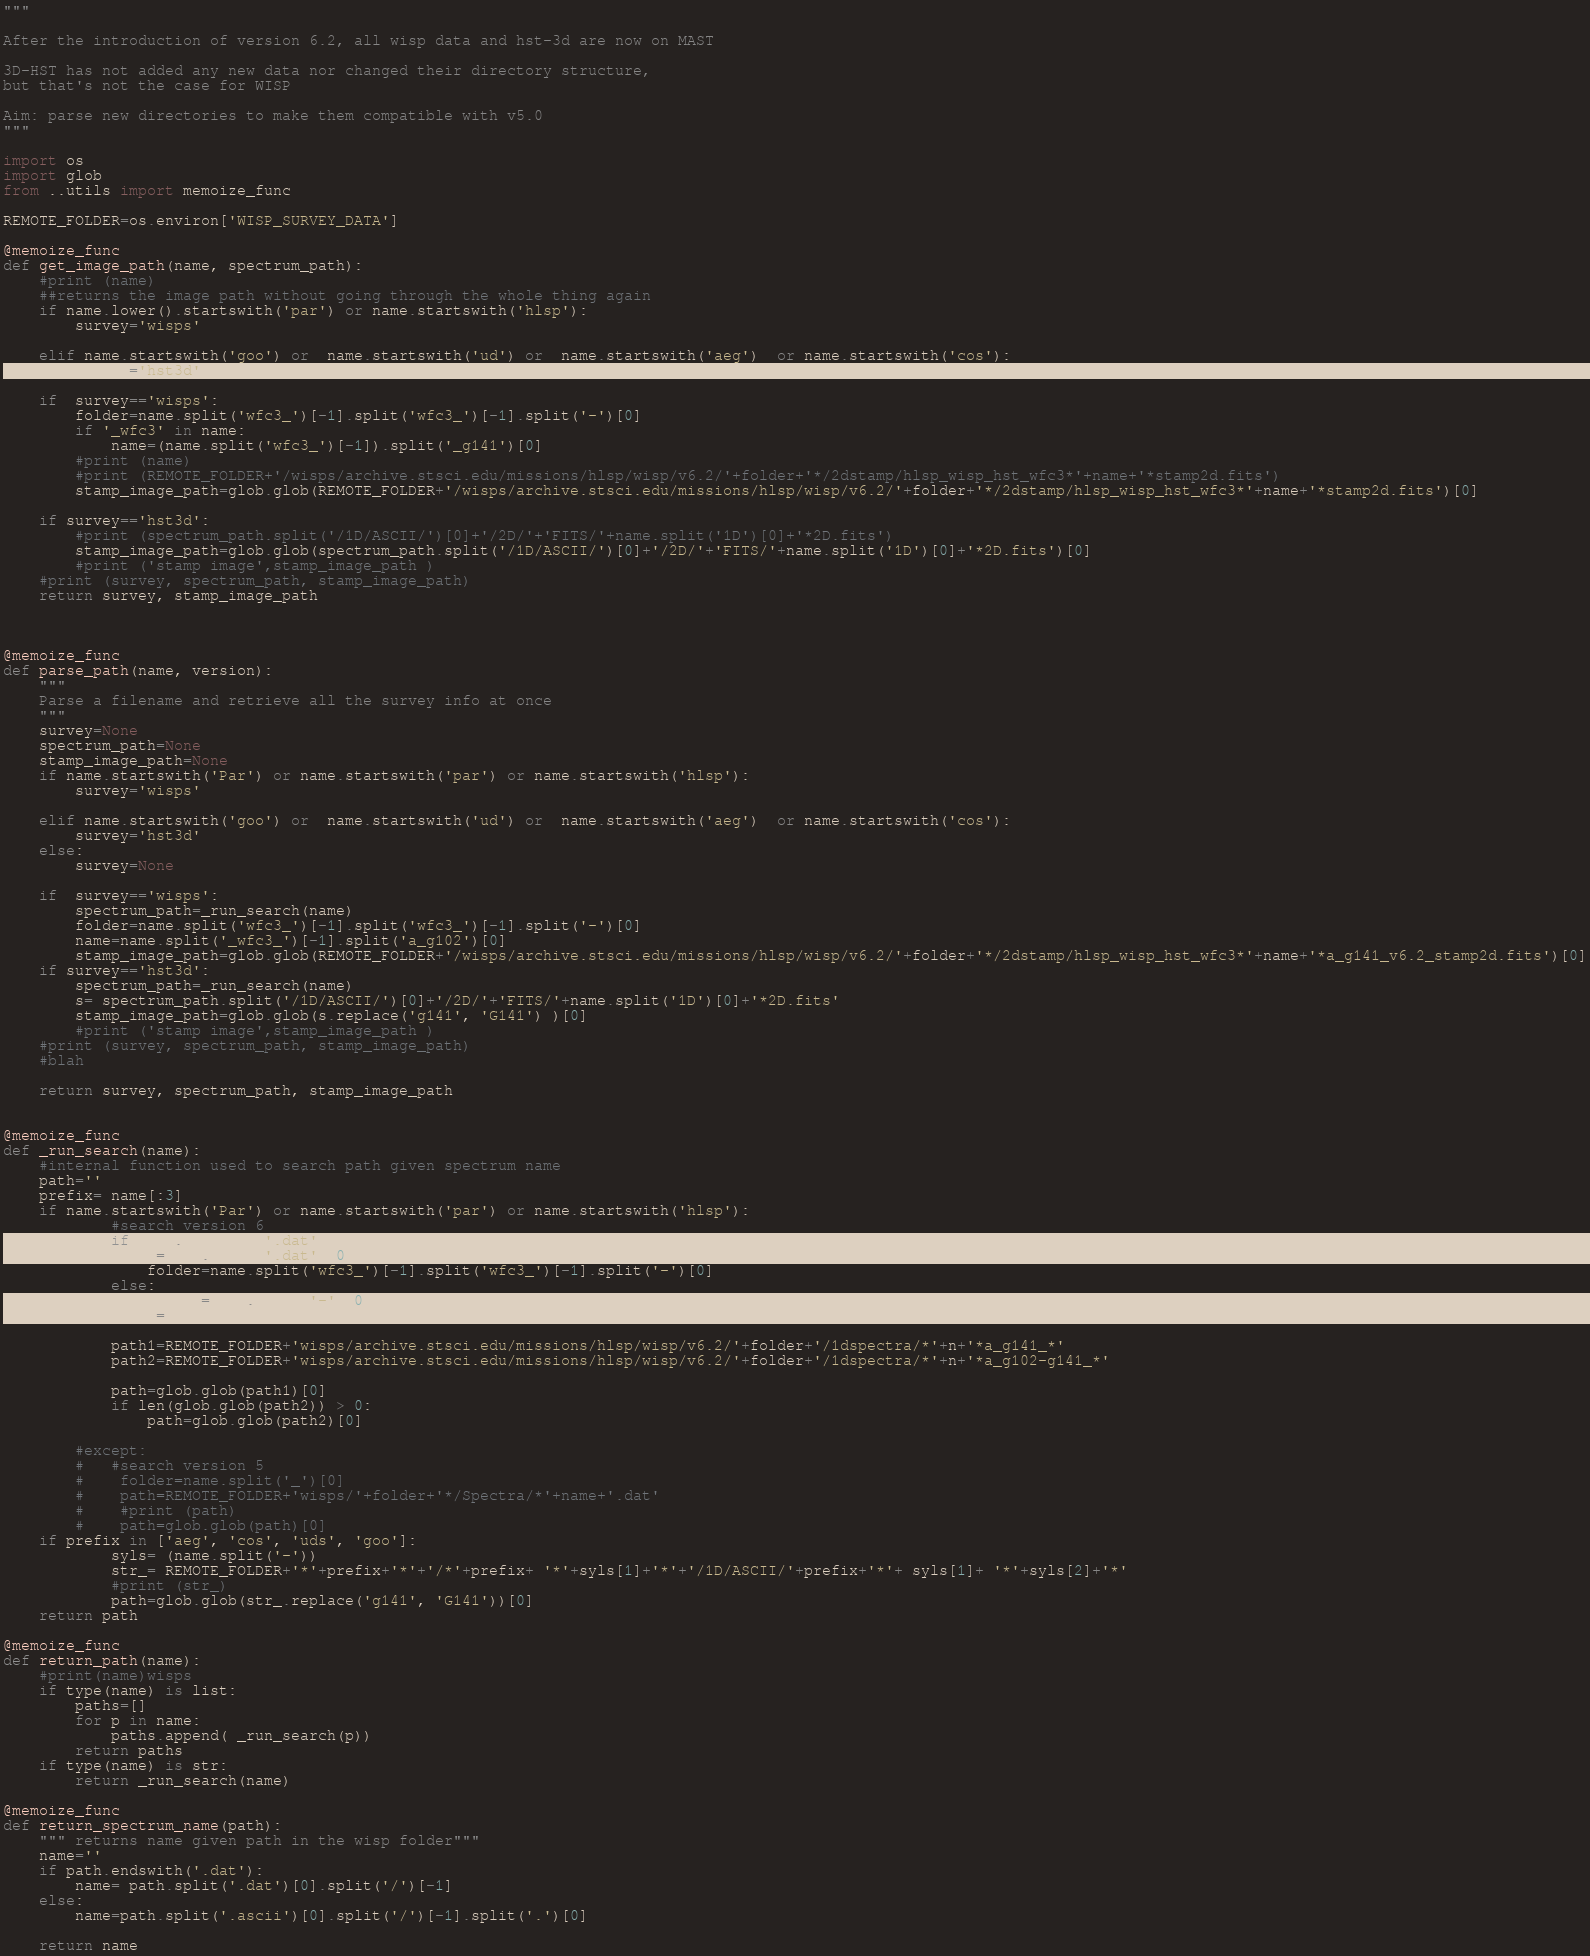<code> <loc_0><loc_0><loc_500><loc_500><_Python_>"""

After the introduction of version 6.2, all wisp data and hst-3d are now on MAST

3D-HST has not added any new data nor changed their directory structure, 
but that's not the case for WISP

Aim: parse new directories to make them compatible with v5.0
"""

import os 
import glob
from ..utils import memoize_func

REMOTE_FOLDER=os.environ['WISP_SURVEY_DATA']

@memoize_func
def get_image_path(name, spectrum_path):
	#print (name)
	##returns the image path without going through the whole thing again
	if name.lower().startswith('par') or name.startswith('hlsp'):
		survey='wisps'

	elif name.startswith('goo') or  name.startswith('ud') or  name.startswith('aeg')  or name.startswith('cos'):
		survey='hst3d'

	if  survey=='wisps':
		folder=name.split('wfc3_')[-1].split('wfc3_')[-1].split('-')[0]
		if '_wfc3' in name:
			name=(name.split('wfc3_')[-1]).split('_g141')[0]
		#print (name)
		#print (REMOTE_FOLDER+'/wisps/archive.stsci.edu/missions/hlsp/wisp/v6.2/'+folder+'*/2dstamp/hlsp_wisp_hst_wfc3*'+name+'*stamp2d.fits')
		stamp_image_path=glob.glob(REMOTE_FOLDER+'/wisps/archive.stsci.edu/missions/hlsp/wisp/v6.2/'+folder+'*/2dstamp/hlsp_wisp_hst_wfc3*'+name+'*stamp2d.fits')[0]

	if survey=='hst3d':
		#print (spectrum_path.split('/1D/ASCII/')[0]+'/2D/'+'FITS/'+name.split('1D')[0]+'*2D.fits')
		stamp_image_path=glob.glob(spectrum_path.split('/1D/ASCII/')[0]+'/2D/'+'FITS/'+name.split('1D')[0]+'*2D.fits')[0]
		#print ('stamp image',stamp_image_path )
	#print (survey, spectrum_path, stamp_image_path)
	return survey, stamp_image_path



@memoize_func
def parse_path(name, version):
	"""
	Parse a filename and retrieve all the survey info at once
	"""
	survey=None
	spectrum_path=None
	stamp_image_path=None
	if name.startswith('Par') or name.startswith('par') or name.startswith('hlsp'): 
		survey='wisps'

	elif name.startswith('goo') or  name.startswith('ud') or  name.startswith('aeg')  or name.startswith('cos'):
		survey='hst3d'
	else:
		survey=None

	if  survey=='wisps':
		spectrum_path=_run_search(name)
		folder=name.split('wfc3_')[-1].split('wfc3_')[-1].split('-')[0]
		name=name.split('_wfc3_')[-1].split('a_g102')[0]
		stamp_image_path=glob.glob(REMOTE_FOLDER+'/wisps/archive.stsci.edu/missions/hlsp/wisp/v6.2/'+folder+'*/2dstamp/hlsp_wisp_hst_wfc3*'+name+'*a_g141_v6.2_stamp2d.fits')[0]
	if survey=='hst3d':
		spectrum_path=_run_search(name)
		s= spectrum_path.split('/1D/ASCII/')[0]+'/2D/'+'FITS/'+name.split('1D')[0]+'*2D.fits'
		stamp_image_path=glob.glob(s.replace('g141', 'G141') )[0]
		#print ('stamp image',stamp_image_path )
	#print (survey, spectrum_path, stamp_image_path)
	#blah

	return survey, spectrum_path, stamp_image_path


@memoize_func
def _run_search(name):
    #internal function used to search path given spectrum name
    path=''
    prefix= name[:3]
    if name.startswith('Par') or name.startswith('par') or name.startswith('hlsp'):
            #search version 6
            if name.endswith('.dat'):
                n=name.split('.dat')[0]
                folder=name.split('wfc3_')[-1].split('wfc3_')[-1].split('-')[0]
            else:
                folder=name.split('-')[0]
                n=name

            path1=REMOTE_FOLDER+'wisps/archive.stsci.edu/missions/hlsp/wisp/v6.2/'+folder+'/1dspectra/*'+n+'*a_g141_*'
            path2=REMOTE_FOLDER+'wisps/archive.stsci.edu/missions/hlsp/wisp/v6.2/'+folder+'/1dspectra/*'+n+'*a_g102-g141_*'

            path=glob.glob(path1)[0]
            if len(glob.glob(path2)) > 0:
            	path=glob.glob(path2)[0]

        #except:
        #   #search version 5
        #    folder=name.split('_')[0]
        #    path=REMOTE_FOLDER+'wisps/'+folder+'*/Spectra/*'+name+'.dat'
        #    #print (path)
        #    path=glob.glob(path)[0]
    if prefix in ['aeg', 'cos', 'uds', 'goo']:
            syls= (name.split('-'))
            str_= REMOTE_FOLDER+'*'+prefix+'*'+'/*'+prefix+ '*'+syls[1]+'*'+'/1D/ASCII/'+prefix+'*'+ syls[1]+ '*'+syls[2]+'*'
            #print (str_)
            path=glob.glob(str_.replace('g141', 'G141'))[0]
    return path

@memoize_func
def return_path(name):
	#print(name)wisps
	if type(name) is list:
		paths=[]
		for p in name:
			paths.append( _run_search(p))
		return paths
	if type(name) is str:
		return _run_search(name)
	
@memoize_func
def return_spectrum_name(path):
	""" returns name given path in the wisp folder"""
	name=''
	if path.endswith('.dat'):
		name= path.split('.dat')[0].split('/')[-1]
	else:
		name=path.split('.ascii')[0].split('/')[-1].split('.')[0]

	return name</code> 